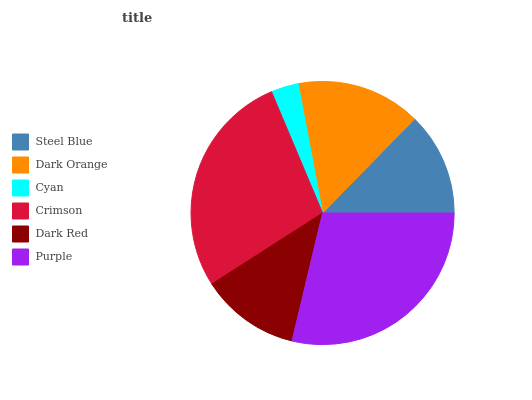Is Cyan the minimum?
Answer yes or no. Yes. Is Purple the maximum?
Answer yes or no. Yes. Is Dark Orange the minimum?
Answer yes or no. No. Is Dark Orange the maximum?
Answer yes or no. No. Is Dark Orange greater than Steel Blue?
Answer yes or no. Yes. Is Steel Blue less than Dark Orange?
Answer yes or no. Yes. Is Steel Blue greater than Dark Orange?
Answer yes or no. No. Is Dark Orange less than Steel Blue?
Answer yes or no. No. Is Dark Orange the high median?
Answer yes or no. Yes. Is Steel Blue the low median?
Answer yes or no. Yes. Is Dark Red the high median?
Answer yes or no. No. Is Dark Orange the low median?
Answer yes or no. No. 